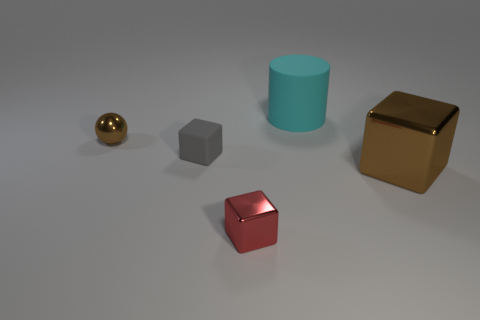What does the choice of colors for the objects convey? The image features objects with varying colors that can be interpreted in different ways. The use of primary colors for two cubes (gold and red) and the secondary color cyan for the cylinder could represent a choice to highlight the differences in shapes through contrasting hues. It creates a visually engaging scene that also serves an educational purpose by demonstrating how different materials and colors interact with the same light source. 